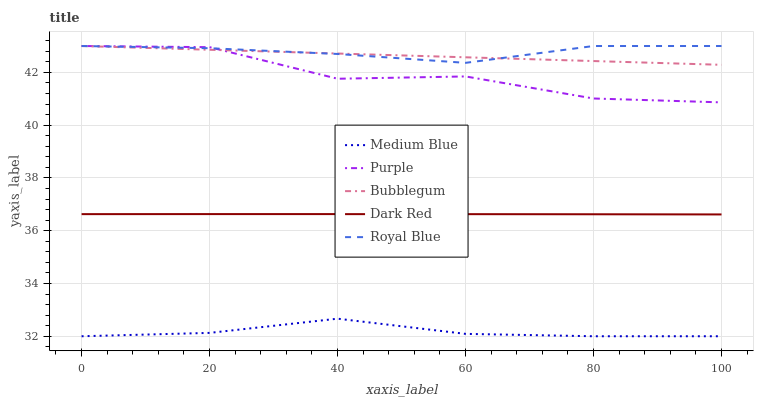Does Medium Blue have the minimum area under the curve?
Answer yes or no. Yes. Does Royal Blue have the maximum area under the curve?
Answer yes or no. Yes. Does Dark Red have the minimum area under the curve?
Answer yes or no. No. Does Dark Red have the maximum area under the curve?
Answer yes or no. No. Is Bubblegum the smoothest?
Answer yes or no. Yes. Is Purple the roughest?
Answer yes or no. Yes. Is Dark Red the smoothest?
Answer yes or no. No. Is Dark Red the roughest?
Answer yes or no. No. Does Medium Blue have the lowest value?
Answer yes or no. Yes. Does Dark Red have the lowest value?
Answer yes or no. No. Does Royal Blue have the highest value?
Answer yes or no. Yes. Does Dark Red have the highest value?
Answer yes or no. No. Is Medium Blue less than Bubblegum?
Answer yes or no. Yes. Is Bubblegum greater than Dark Red?
Answer yes or no. Yes. Does Royal Blue intersect Bubblegum?
Answer yes or no. Yes. Is Royal Blue less than Bubblegum?
Answer yes or no. No. Is Royal Blue greater than Bubblegum?
Answer yes or no. No. Does Medium Blue intersect Bubblegum?
Answer yes or no. No. 